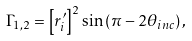Convert formula to latex. <formula><loc_0><loc_0><loc_500><loc_500>\Gamma _ { 1 , 2 } & = \left [ r ^ { \prime } _ { i } \right ] ^ { 2 } \sin \left ( \pi - 2 \theta _ { i n c } \right ) ,</formula> 